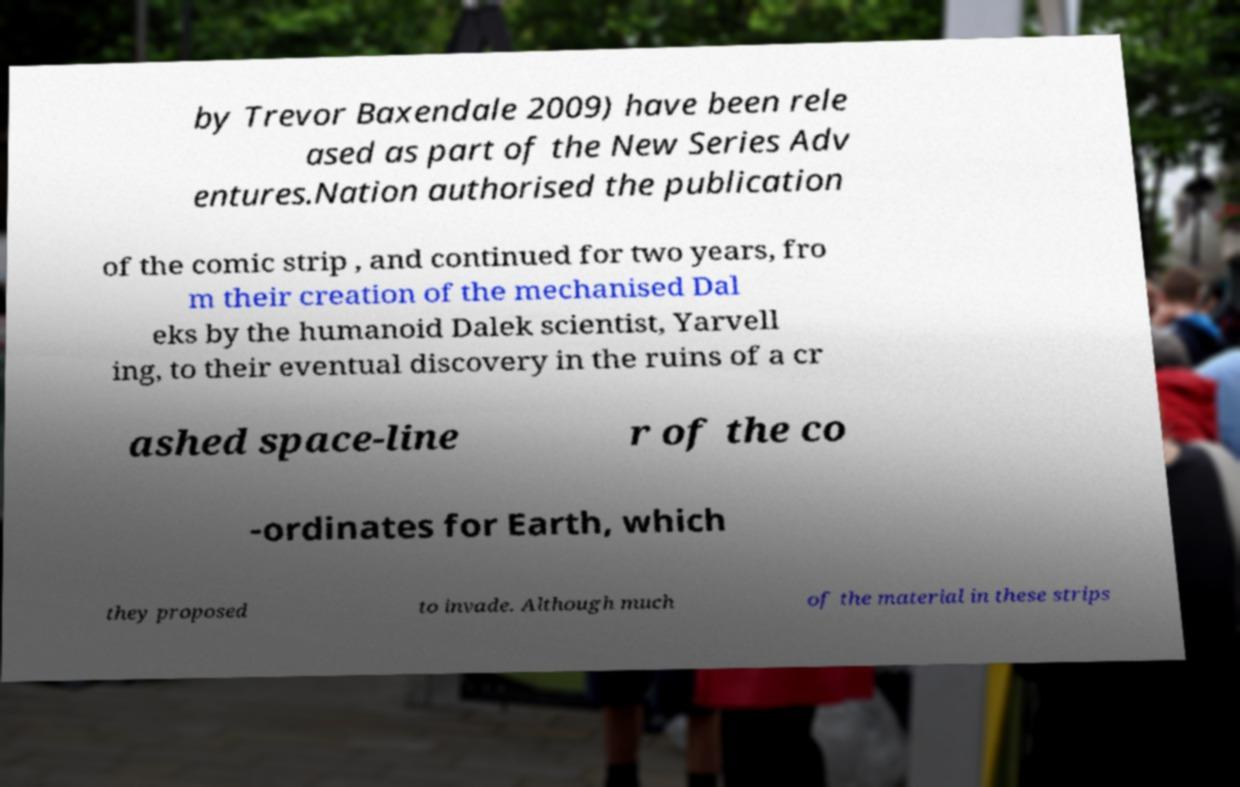What messages or text are displayed in this image? I need them in a readable, typed format. by Trevor Baxendale 2009) have been rele ased as part of the New Series Adv entures.Nation authorised the publication of the comic strip , and continued for two years, fro m their creation of the mechanised Dal eks by the humanoid Dalek scientist, Yarvell ing, to their eventual discovery in the ruins of a cr ashed space-line r of the co -ordinates for Earth, which they proposed to invade. Although much of the material in these strips 